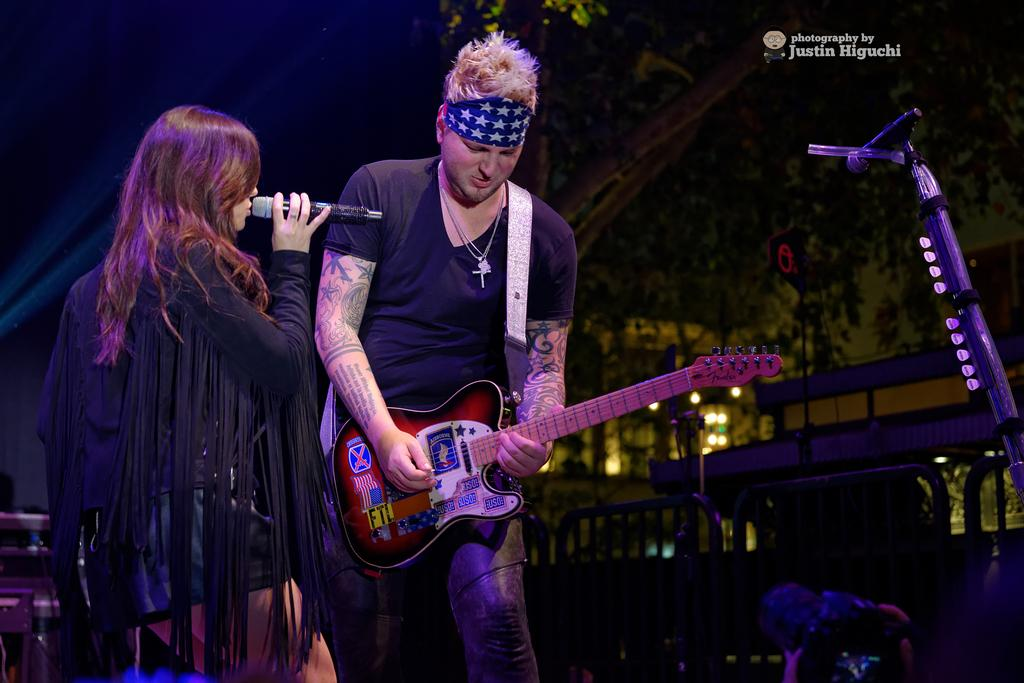What is the woman in the image holding? The woman is holding a microphone. What is the man in the image holding? The man is holding a guitar. Can you describe the background of the image? There is a tree in the background of the image. How many houses can be seen in the image? There are no houses visible in the image. What type of flower is the girl holding in the image? There is no girl or flower present in the image. 